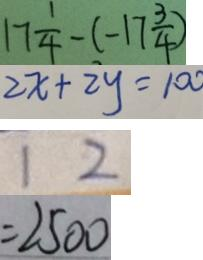<formula> <loc_0><loc_0><loc_500><loc_500>1 7 \frac { 1 } { 4 } - ( - 1 7 \frac { 3 } { 4 } ) 
 2 x + 2 y = 1 0 0 
 1 2 
 = 2 5 0 0</formula> 